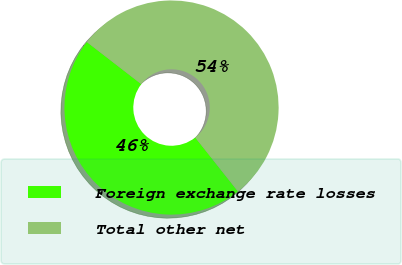<chart> <loc_0><loc_0><loc_500><loc_500><pie_chart><fcel>Foreign exchange rate losses<fcel>Total other net<nl><fcel>46.15%<fcel>53.85%<nl></chart> 